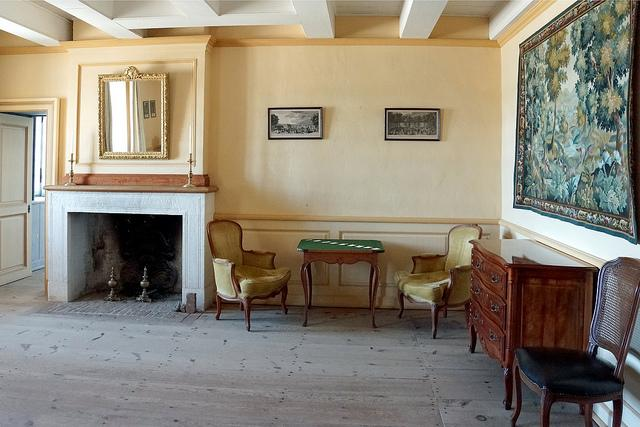Where are the candles placed in the room? mantle 